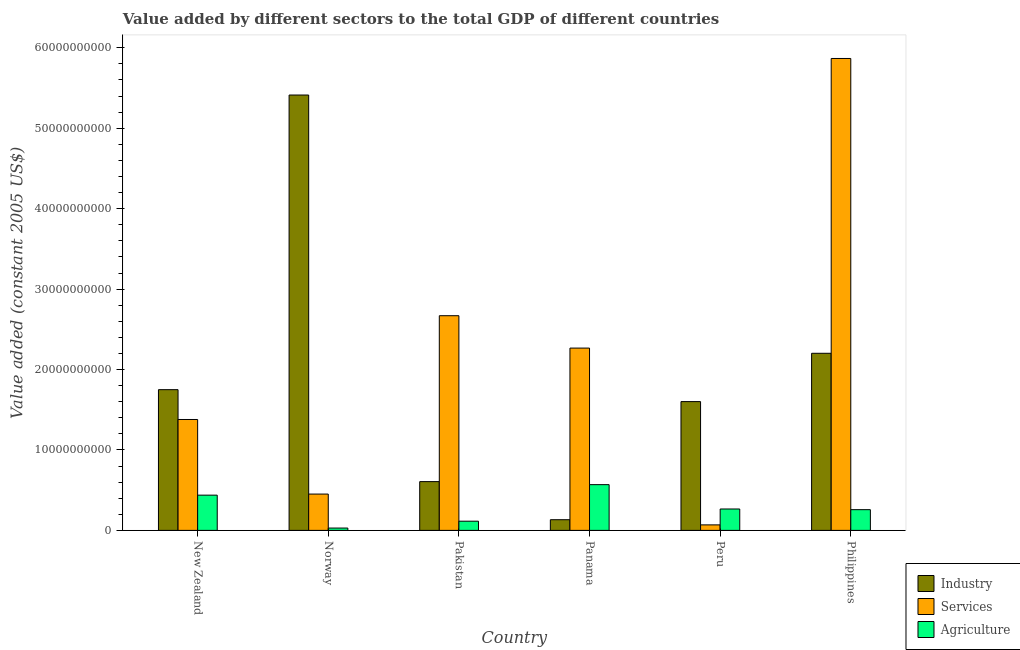How many groups of bars are there?
Offer a terse response. 6. Are the number of bars per tick equal to the number of legend labels?
Ensure brevity in your answer.  Yes. How many bars are there on the 3rd tick from the left?
Ensure brevity in your answer.  3. What is the label of the 3rd group of bars from the left?
Provide a succinct answer. Pakistan. In how many cases, is the number of bars for a given country not equal to the number of legend labels?
Offer a terse response. 0. What is the value added by services in Philippines?
Offer a terse response. 5.87e+1. Across all countries, what is the maximum value added by services?
Give a very brief answer. 5.87e+1. Across all countries, what is the minimum value added by industrial sector?
Your response must be concise. 1.33e+09. In which country was the value added by industrial sector minimum?
Ensure brevity in your answer.  Panama. What is the total value added by agricultural sector in the graph?
Ensure brevity in your answer.  1.67e+1. What is the difference between the value added by services in Norway and that in Panama?
Keep it short and to the point. -1.82e+1. What is the difference between the value added by services in Norway and the value added by agricultural sector in Pakistan?
Ensure brevity in your answer.  3.37e+09. What is the average value added by industrial sector per country?
Provide a succinct answer. 1.95e+1. What is the difference between the value added by industrial sector and value added by services in Pakistan?
Provide a succinct answer. -2.06e+1. What is the ratio of the value added by industrial sector in Panama to that in Peru?
Provide a short and direct response. 0.08. What is the difference between the highest and the second highest value added by agricultural sector?
Provide a short and direct response. 1.30e+09. What is the difference between the highest and the lowest value added by agricultural sector?
Your answer should be compact. 5.40e+09. In how many countries, is the value added by services greater than the average value added by services taken over all countries?
Your response must be concise. 3. What does the 2nd bar from the left in Philippines represents?
Your answer should be very brief. Services. What does the 3rd bar from the right in Norway represents?
Your response must be concise. Industry. Are all the bars in the graph horizontal?
Keep it short and to the point. No. Are the values on the major ticks of Y-axis written in scientific E-notation?
Offer a terse response. No. Where does the legend appear in the graph?
Provide a short and direct response. Bottom right. What is the title of the graph?
Make the answer very short. Value added by different sectors to the total GDP of different countries. What is the label or title of the Y-axis?
Give a very brief answer. Value added (constant 2005 US$). What is the Value added (constant 2005 US$) in Industry in New Zealand?
Your answer should be very brief. 1.75e+1. What is the Value added (constant 2005 US$) in Services in New Zealand?
Ensure brevity in your answer.  1.38e+1. What is the Value added (constant 2005 US$) in Agriculture in New Zealand?
Keep it short and to the point. 4.38e+09. What is the Value added (constant 2005 US$) of Industry in Norway?
Ensure brevity in your answer.  5.41e+1. What is the Value added (constant 2005 US$) of Services in Norway?
Make the answer very short. 4.51e+09. What is the Value added (constant 2005 US$) of Agriculture in Norway?
Give a very brief answer. 2.90e+08. What is the Value added (constant 2005 US$) in Industry in Pakistan?
Your response must be concise. 6.06e+09. What is the Value added (constant 2005 US$) of Services in Pakistan?
Offer a very short reply. 2.67e+1. What is the Value added (constant 2005 US$) in Agriculture in Pakistan?
Make the answer very short. 1.14e+09. What is the Value added (constant 2005 US$) of Industry in Panama?
Provide a succinct answer. 1.33e+09. What is the Value added (constant 2005 US$) of Services in Panama?
Make the answer very short. 2.27e+1. What is the Value added (constant 2005 US$) of Agriculture in Panama?
Offer a very short reply. 5.69e+09. What is the Value added (constant 2005 US$) of Industry in Peru?
Offer a very short reply. 1.60e+1. What is the Value added (constant 2005 US$) of Services in Peru?
Offer a very short reply. 6.85e+08. What is the Value added (constant 2005 US$) of Agriculture in Peru?
Make the answer very short. 2.66e+09. What is the Value added (constant 2005 US$) of Industry in Philippines?
Provide a short and direct response. 2.20e+1. What is the Value added (constant 2005 US$) of Services in Philippines?
Provide a succinct answer. 5.87e+1. What is the Value added (constant 2005 US$) of Agriculture in Philippines?
Provide a short and direct response. 2.58e+09. Across all countries, what is the maximum Value added (constant 2005 US$) of Industry?
Give a very brief answer. 5.41e+1. Across all countries, what is the maximum Value added (constant 2005 US$) in Services?
Your response must be concise. 5.87e+1. Across all countries, what is the maximum Value added (constant 2005 US$) in Agriculture?
Provide a short and direct response. 5.69e+09. Across all countries, what is the minimum Value added (constant 2005 US$) in Industry?
Provide a short and direct response. 1.33e+09. Across all countries, what is the minimum Value added (constant 2005 US$) in Services?
Offer a very short reply. 6.85e+08. Across all countries, what is the minimum Value added (constant 2005 US$) in Agriculture?
Provide a short and direct response. 2.90e+08. What is the total Value added (constant 2005 US$) in Industry in the graph?
Provide a succinct answer. 1.17e+11. What is the total Value added (constant 2005 US$) of Services in the graph?
Ensure brevity in your answer.  1.27e+11. What is the total Value added (constant 2005 US$) of Agriculture in the graph?
Give a very brief answer. 1.67e+1. What is the difference between the Value added (constant 2005 US$) of Industry in New Zealand and that in Norway?
Provide a succinct answer. -3.66e+1. What is the difference between the Value added (constant 2005 US$) of Services in New Zealand and that in Norway?
Offer a terse response. 9.27e+09. What is the difference between the Value added (constant 2005 US$) of Agriculture in New Zealand and that in Norway?
Make the answer very short. 4.09e+09. What is the difference between the Value added (constant 2005 US$) in Industry in New Zealand and that in Pakistan?
Offer a terse response. 1.14e+1. What is the difference between the Value added (constant 2005 US$) in Services in New Zealand and that in Pakistan?
Your answer should be very brief. -1.29e+1. What is the difference between the Value added (constant 2005 US$) of Agriculture in New Zealand and that in Pakistan?
Offer a very short reply. 3.24e+09. What is the difference between the Value added (constant 2005 US$) of Industry in New Zealand and that in Panama?
Make the answer very short. 1.62e+1. What is the difference between the Value added (constant 2005 US$) in Services in New Zealand and that in Panama?
Your answer should be very brief. -8.88e+09. What is the difference between the Value added (constant 2005 US$) of Agriculture in New Zealand and that in Panama?
Provide a succinct answer. -1.30e+09. What is the difference between the Value added (constant 2005 US$) in Industry in New Zealand and that in Peru?
Provide a succinct answer. 1.48e+09. What is the difference between the Value added (constant 2005 US$) in Services in New Zealand and that in Peru?
Provide a succinct answer. 1.31e+1. What is the difference between the Value added (constant 2005 US$) of Agriculture in New Zealand and that in Peru?
Give a very brief answer. 1.72e+09. What is the difference between the Value added (constant 2005 US$) of Industry in New Zealand and that in Philippines?
Your answer should be compact. -4.52e+09. What is the difference between the Value added (constant 2005 US$) of Services in New Zealand and that in Philippines?
Your response must be concise. -4.49e+1. What is the difference between the Value added (constant 2005 US$) in Agriculture in New Zealand and that in Philippines?
Offer a terse response. 1.81e+09. What is the difference between the Value added (constant 2005 US$) in Industry in Norway and that in Pakistan?
Provide a short and direct response. 4.81e+1. What is the difference between the Value added (constant 2005 US$) of Services in Norway and that in Pakistan?
Provide a succinct answer. -2.22e+1. What is the difference between the Value added (constant 2005 US$) in Agriculture in Norway and that in Pakistan?
Your answer should be very brief. -8.53e+08. What is the difference between the Value added (constant 2005 US$) of Industry in Norway and that in Panama?
Offer a very short reply. 5.28e+1. What is the difference between the Value added (constant 2005 US$) in Services in Norway and that in Panama?
Offer a terse response. -1.82e+1. What is the difference between the Value added (constant 2005 US$) in Agriculture in Norway and that in Panama?
Your answer should be very brief. -5.40e+09. What is the difference between the Value added (constant 2005 US$) of Industry in Norway and that in Peru?
Keep it short and to the point. 3.81e+1. What is the difference between the Value added (constant 2005 US$) of Services in Norway and that in Peru?
Keep it short and to the point. 3.83e+09. What is the difference between the Value added (constant 2005 US$) of Agriculture in Norway and that in Peru?
Your answer should be compact. -2.37e+09. What is the difference between the Value added (constant 2005 US$) of Industry in Norway and that in Philippines?
Give a very brief answer. 3.21e+1. What is the difference between the Value added (constant 2005 US$) in Services in Norway and that in Philippines?
Your answer should be very brief. -5.42e+1. What is the difference between the Value added (constant 2005 US$) of Agriculture in Norway and that in Philippines?
Offer a terse response. -2.29e+09. What is the difference between the Value added (constant 2005 US$) in Industry in Pakistan and that in Panama?
Your answer should be compact. 4.74e+09. What is the difference between the Value added (constant 2005 US$) in Services in Pakistan and that in Panama?
Offer a terse response. 4.03e+09. What is the difference between the Value added (constant 2005 US$) in Agriculture in Pakistan and that in Panama?
Give a very brief answer. -4.54e+09. What is the difference between the Value added (constant 2005 US$) of Industry in Pakistan and that in Peru?
Keep it short and to the point. -9.95e+09. What is the difference between the Value added (constant 2005 US$) of Services in Pakistan and that in Peru?
Make the answer very short. 2.60e+1. What is the difference between the Value added (constant 2005 US$) of Agriculture in Pakistan and that in Peru?
Your response must be concise. -1.52e+09. What is the difference between the Value added (constant 2005 US$) of Industry in Pakistan and that in Philippines?
Offer a very short reply. -1.60e+1. What is the difference between the Value added (constant 2005 US$) of Services in Pakistan and that in Philippines?
Make the answer very short. -3.20e+1. What is the difference between the Value added (constant 2005 US$) in Agriculture in Pakistan and that in Philippines?
Give a very brief answer. -1.43e+09. What is the difference between the Value added (constant 2005 US$) of Industry in Panama and that in Peru?
Provide a succinct answer. -1.47e+1. What is the difference between the Value added (constant 2005 US$) of Services in Panama and that in Peru?
Ensure brevity in your answer.  2.20e+1. What is the difference between the Value added (constant 2005 US$) in Agriculture in Panama and that in Peru?
Provide a succinct answer. 3.03e+09. What is the difference between the Value added (constant 2005 US$) of Industry in Panama and that in Philippines?
Provide a succinct answer. -2.07e+1. What is the difference between the Value added (constant 2005 US$) of Services in Panama and that in Philippines?
Give a very brief answer. -3.60e+1. What is the difference between the Value added (constant 2005 US$) of Agriculture in Panama and that in Philippines?
Provide a short and direct response. 3.11e+09. What is the difference between the Value added (constant 2005 US$) of Industry in Peru and that in Philippines?
Offer a very short reply. -6.01e+09. What is the difference between the Value added (constant 2005 US$) of Services in Peru and that in Philippines?
Ensure brevity in your answer.  -5.80e+1. What is the difference between the Value added (constant 2005 US$) of Agriculture in Peru and that in Philippines?
Your answer should be compact. 8.38e+07. What is the difference between the Value added (constant 2005 US$) of Industry in New Zealand and the Value added (constant 2005 US$) of Services in Norway?
Make the answer very short. 1.30e+1. What is the difference between the Value added (constant 2005 US$) of Industry in New Zealand and the Value added (constant 2005 US$) of Agriculture in Norway?
Provide a succinct answer. 1.72e+1. What is the difference between the Value added (constant 2005 US$) of Services in New Zealand and the Value added (constant 2005 US$) of Agriculture in Norway?
Provide a succinct answer. 1.35e+1. What is the difference between the Value added (constant 2005 US$) in Industry in New Zealand and the Value added (constant 2005 US$) in Services in Pakistan?
Ensure brevity in your answer.  -9.19e+09. What is the difference between the Value added (constant 2005 US$) of Industry in New Zealand and the Value added (constant 2005 US$) of Agriculture in Pakistan?
Offer a very short reply. 1.64e+1. What is the difference between the Value added (constant 2005 US$) in Services in New Zealand and the Value added (constant 2005 US$) in Agriculture in Pakistan?
Provide a succinct answer. 1.26e+1. What is the difference between the Value added (constant 2005 US$) in Industry in New Zealand and the Value added (constant 2005 US$) in Services in Panama?
Provide a short and direct response. -5.17e+09. What is the difference between the Value added (constant 2005 US$) in Industry in New Zealand and the Value added (constant 2005 US$) in Agriculture in Panama?
Offer a terse response. 1.18e+1. What is the difference between the Value added (constant 2005 US$) in Services in New Zealand and the Value added (constant 2005 US$) in Agriculture in Panama?
Keep it short and to the point. 8.10e+09. What is the difference between the Value added (constant 2005 US$) of Industry in New Zealand and the Value added (constant 2005 US$) of Services in Peru?
Your answer should be compact. 1.68e+1. What is the difference between the Value added (constant 2005 US$) in Industry in New Zealand and the Value added (constant 2005 US$) in Agriculture in Peru?
Give a very brief answer. 1.48e+1. What is the difference between the Value added (constant 2005 US$) in Services in New Zealand and the Value added (constant 2005 US$) in Agriculture in Peru?
Give a very brief answer. 1.11e+1. What is the difference between the Value added (constant 2005 US$) of Industry in New Zealand and the Value added (constant 2005 US$) of Services in Philippines?
Your answer should be very brief. -4.12e+1. What is the difference between the Value added (constant 2005 US$) of Industry in New Zealand and the Value added (constant 2005 US$) of Agriculture in Philippines?
Your response must be concise. 1.49e+1. What is the difference between the Value added (constant 2005 US$) in Services in New Zealand and the Value added (constant 2005 US$) in Agriculture in Philippines?
Provide a succinct answer. 1.12e+1. What is the difference between the Value added (constant 2005 US$) of Industry in Norway and the Value added (constant 2005 US$) of Services in Pakistan?
Provide a succinct answer. 2.74e+1. What is the difference between the Value added (constant 2005 US$) of Industry in Norway and the Value added (constant 2005 US$) of Agriculture in Pakistan?
Your response must be concise. 5.30e+1. What is the difference between the Value added (constant 2005 US$) of Services in Norway and the Value added (constant 2005 US$) of Agriculture in Pakistan?
Provide a short and direct response. 3.37e+09. What is the difference between the Value added (constant 2005 US$) of Industry in Norway and the Value added (constant 2005 US$) of Services in Panama?
Ensure brevity in your answer.  3.15e+1. What is the difference between the Value added (constant 2005 US$) in Industry in Norway and the Value added (constant 2005 US$) in Agriculture in Panama?
Offer a terse response. 4.84e+1. What is the difference between the Value added (constant 2005 US$) in Services in Norway and the Value added (constant 2005 US$) in Agriculture in Panama?
Give a very brief answer. -1.17e+09. What is the difference between the Value added (constant 2005 US$) of Industry in Norway and the Value added (constant 2005 US$) of Services in Peru?
Give a very brief answer. 5.34e+1. What is the difference between the Value added (constant 2005 US$) in Industry in Norway and the Value added (constant 2005 US$) in Agriculture in Peru?
Your response must be concise. 5.15e+1. What is the difference between the Value added (constant 2005 US$) in Services in Norway and the Value added (constant 2005 US$) in Agriculture in Peru?
Make the answer very short. 1.85e+09. What is the difference between the Value added (constant 2005 US$) of Industry in Norway and the Value added (constant 2005 US$) of Services in Philippines?
Offer a terse response. -4.54e+09. What is the difference between the Value added (constant 2005 US$) of Industry in Norway and the Value added (constant 2005 US$) of Agriculture in Philippines?
Your answer should be compact. 5.16e+1. What is the difference between the Value added (constant 2005 US$) in Services in Norway and the Value added (constant 2005 US$) in Agriculture in Philippines?
Keep it short and to the point. 1.94e+09. What is the difference between the Value added (constant 2005 US$) in Industry in Pakistan and the Value added (constant 2005 US$) in Services in Panama?
Make the answer very short. -1.66e+1. What is the difference between the Value added (constant 2005 US$) in Industry in Pakistan and the Value added (constant 2005 US$) in Agriculture in Panama?
Make the answer very short. 3.77e+08. What is the difference between the Value added (constant 2005 US$) of Services in Pakistan and the Value added (constant 2005 US$) of Agriculture in Panama?
Keep it short and to the point. 2.10e+1. What is the difference between the Value added (constant 2005 US$) of Industry in Pakistan and the Value added (constant 2005 US$) of Services in Peru?
Your answer should be compact. 5.38e+09. What is the difference between the Value added (constant 2005 US$) of Industry in Pakistan and the Value added (constant 2005 US$) of Agriculture in Peru?
Give a very brief answer. 3.40e+09. What is the difference between the Value added (constant 2005 US$) of Services in Pakistan and the Value added (constant 2005 US$) of Agriculture in Peru?
Your answer should be compact. 2.40e+1. What is the difference between the Value added (constant 2005 US$) of Industry in Pakistan and the Value added (constant 2005 US$) of Services in Philippines?
Provide a succinct answer. -5.26e+1. What is the difference between the Value added (constant 2005 US$) in Industry in Pakistan and the Value added (constant 2005 US$) in Agriculture in Philippines?
Your answer should be compact. 3.49e+09. What is the difference between the Value added (constant 2005 US$) in Services in Pakistan and the Value added (constant 2005 US$) in Agriculture in Philippines?
Your response must be concise. 2.41e+1. What is the difference between the Value added (constant 2005 US$) of Industry in Panama and the Value added (constant 2005 US$) of Services in Peru?
Provide a short and direct response. 6.44e+08. What is the difference between the Value added (constant 2005 US$) in Industry in Panama and the Value added (constant 2005 US$) in Agriculture in Peru?
Your answer should be very brief. -1.33e+09. What is the difference between the Value added (constant 2005 US$) of Services in Panama and the Value added (constant 2005 US$) of Agriculture in Peru?
Your response must be concise. 2.00e+1. What is the difference between the Value added (constant 2005 US$) in Industry in Panama and the Value added (constant 2005 US$) in Services in Philippines?
Keep it short and to the point. -5.73e+1. What is the difference between the Value added (constant 2005 US$) of Industry in Panama and the Value added (constant 2005 US$) of Agriculture in Philippines?
Offer a very short reply. -1.25e+09. What is the difference between the Value added (constant 2005 US$) of Services in Panama and the Value added (constant 2005 US$) of Agriculture in Philippines?
Provide a short and direct response. 2.01e+1. What is the difference between the Value added (constant 2005 US$) in Industry in Peru and the Value added (constant 2005 US$) in Services in Philippines?
Your answer should be compact. -4.27e+1. What is the difference between the Value added (constant 2005 US$) of Industry in Peru and the Value added (constant 2005 US$) of Agriculture in Philippines?
Give a very brief answer. 1.34e+1. What is the difference between the Value added (constant 2005 US$) of Services in Peru and the Value added (constant 2005 US$) of Agriculture in Philippines?
Your response must be concise. -1.89e+09. What is the average Value added (constant 2005 US$) of Industry per country?
Provide a succinct answer. 1.95e+1. What is the average Value added (constant 2005 US$) in Services per country?
Your answer should be compact. 2.12e+1. What is the average Value added (constant 2005 US$) in Agriculture per country?
Your answer should be very brief. 2.79e+09. What is the difference between the Value added (constant 2005 US$) of Industry and Value added (constant 2005 US$) of Services in New Zealand?
Your answer should be very brief. 3.71e+09. What is the difference between the Value added (constant 2005 US$) of Industry and Value added (constant 2005 US$) of Agriculture in New Zealand?
Your response must be concise. 1.31e+1. What is the difference between the Value added (constant 2005 US$) of Services and Value added (constant 2005 US$) of Agriculture in New Zealand?
Offer a terse response. 9.40e+09. What is the difference between the Value added (constant 2005 US$) of Industry and Value added (constant 2005 US$) of Services in Norway?
Make the answer very short. 4.96e+1. What is the difference between the Value added (constant 2005 US$) of Industry and Value added (constant 2005 US$) of Agriculture in Norway?
Ensure brevity in your answer.  5.38e+1. What is the difference between the Value added (constant 2005 US$) of Services and Value added (constant 2005 US$) of Agriculture in Norway?
Your response must be concise. 4.22e+09. What is the difference between the Value added (constant 2005 US$) of Industry and Value added (constant 2005 US$) of Services in Pakistan?
Your answer should be compact. -2.06e+1. What is the difference between the Value added (constant 2005 US$) in Industry and Value added (constant 2005 US$) in Agriculture in Pakistan?
Keep it short and to the point. 4.92e+09. What is the difference between the Value added (constant 2005 US$) in Services and Value added (constant 2005 US$) in Agriculture in Pakistan?
Make the answer very short. 2.55e+1. What is the difference between the Value added (constant 2005 US$) of Industry and Value added (constant 2005 US$) of Services in Panama?
Offer a very short reply. -2.13e+1. What is the difference between the Value added (constant 2005 US$) of Industry and Value added (constant 2005 US$) of Agriculture in Panama?
Offer a terse response. -4.36e+09. What is the difference between the Value added (constant 2005 US$) in Services and Value added (constant 2005 US$) in Agriculture in Panama?
Make the answer very short. 1.70e+1. What is the difference between the Value added (constant 2005 US$) in Industry and Value added (constant 2005 US$) in Services in Peru?
Keep it short and to the point. 1.53e+1. What is the difference between the Value added (constant 2005 US$) of Industry and Value added (constant 2005 US$) of Agriculture in Peru?
Provide a short and direct response. 1.34e+1. What is the difference between the Value added (constant 2005 US$) in Services and Value added (constant 2005 US$) in Agriculture in Peru?
Offer a very short reply. -1.98e+09. What is the difference between the Value added (constant 2005 US$) in Industry and Value added (constant 2005 US$) in Services in Philippines?
Keep it short and to the point. -3.67e+1. What is the difference between the Value added (constant 2005 US$) in Industry and Value added (constant 2005 US$) in Agriculture in Philippines?
Offer a very short reply. 1.94e+1. What is the difference between the Value added (constant 2005 US$) in Services and Value added (constant 2005 US$) in Agriculture in Philippines?
Keep it short and to the point. 5.61e+1. What is the ratio of the Value added (constant 2005 US$) in Industry in New Zealand to that in Norway?
Your answer should be compact. 0.32. What is the ratio of the Value added (constant 2005 US$) of Services in New Zealand to that in Norway?
Keep it short and to the point. 3.05. What is the ratio of the Value added (constant 2005 US$) in Agriculture in New Zealand to that in Norway?
Provide a succinct answer. 15.1. What is the ratio of the Value added (constant 2005 US$) in Industry in New Zealand to that in Pakistan?
Your response must be concise. 2.89. What is the ratio of the Value added (constant 2005 US$) in Services in New Zealand to that in Pakistan?
Offer a terse response. 0.52. What is the ratio of the Value added (constant 2005 US$) of Agriculture in New Zealand to that in Pakistan?
Make the answer very short. 3.83. What is the ratio of the Value added (constant 2005 US$) in Industry in New Zealand to that in Panama?
Provide a short and direct response. 13.17. What is the ratio of the Value added (constant 2005 US$) of Services in New Zealand to that in Panama?
Ensure brevity in your answer.  0.61. What is the ratio of the Value added (constant 2005 US$) of Agriculture in New Zealand to that in Panama?
Ensure brevity in your answer.  0.77. What is the ratio of the Value added (constant 2005 US$) in Industry in New Zealand to that in Peru?
Ensure brevity in your answer.  1.09. What is the ratio of the Value added (constant 2005 US$) in Services in New Zealand to that in Peru?
Provide a succinct answer. 20.13. What is the ratio of the Value added (constant 2005 US$) in Agriculture in New Zealand to that in Peru?
Ensure brevity in your answer.  1.65. What is the ratio of the Value added (constant 2005 US$) in Industry in New Zealand to that in Philippines?
Offer a very short reply. 0.79. What is the ratio of the Value added (constant 2005 US$) in Services in New Zealand to that in Philippines?
Provide a short and direct response. 0.23. What is the ratio of the Value added (constant 2005 US$) in Agriculture in New Zealand to that in Philippines?
Keep it short and to the point. 1.7. What is the ratio of the Value added (constant 2005 US$) in Industry in Norway to that in Pakistan?
Make the answer very short. 8.93. What is the ratio of the Value added (constant 2005 US$) of Services in Norway to that in Pakistan?
Your response must be concise. 0.17. What is the ratio of the Value added (constant 2005 US$) of Agriculture in Norway to that in Pakistan?
Offer a terse response. 0.25. What is the ratio of the Value added (constant 2005 US$) of Industry in Norway to that in Panama?
Your response must be concise. 40.74. What is the ratio of the Value added (constant 2005 US$) in Services in Norway to that in Panama?
Keep it short and to the point. 0.2. What is the ratio of the Value added (constant 2005 US$) in Agriculture in Norway to that in Panama?
Provide a succinct answer. 0.05. What is the ratio of the Value added (constant 2005 US$) in Industry in Norway to that in Peru?
Your response must be concise. 3.38. What is the ratio of the Value added (constant 2005 US$) of Services in Norway to that in Peru?
Your response must be concise. 6.59. What is the ratio of the Value added (constant 2005 US$) in Agriculture in Norway to that in Peru?
Provide a succinct answer. 0.11. What is the ratio of the Value added (constant 2005 US$) of Industry in Norway to that in Philippines?
Make the answer very short. 2.46. What is the ratio of the Value added (constant 2005 US$) in Services in Norway to that in Philippines?
Your answer should be compact. 0.08. What is the ratio of the Value added (constant 2005 US$) in Agriculture in Norway to that in Philippines?
Provide a succinct answer. 0.11. What is the ratio of the Value added (constant 2005 US$) of Industry in Pakistan to that in Panama?
Your answer should be very brief. 4.56. What is the ratio of the Value added (constant 2005 US$) in Services in Pakistan to that in Panama?
Offer a very short reply. 1.18. What is the ratio of the Value added (constant 2005 US$) of Agriculture in Pakistan to that in Panama?
Provide a succinct answer. 0.2. What is the ratio of the Value added (constant 2005 US$) of Industry in Pakistan to that in Peru?
Make the answer very short. 0.38. What is the ratio of the Value added (constant 2005 US$) in Services in Pakistan to that in Peru?
Provide a short and direct response. 38.97. What is the ratio of the Value added (constant 2005 US$) in Agriculture in Pakistan to that in Peru?
Offer a very short reply. 0.43. What is the ratio of the Value added (constant 2005 US$) of Industry in Pakistan to that in Philippines?
Your answer should be compact. 0.28. What is the ratio of the Value added (constant 2005 US$) of Services in Pakistan to that in Philippines?
Provide a succinct answer. 0.45. What is the ratio of the Value added (constant 2005 US$) in Agriculture in Pakistan to that in Philippines?
Your response must be concise. 0.44. What is the ratio of the Value added (constant 2005 US$) in Industry in Panama to that in Peru?
Your answer should be compact. 0.08. What is the ratio of the Value added (constant 2005 US$) of Services in Panama to that in Peru?
Provide a short and direct response. 33.1. What is the ratio of the Value added (constant 2005 US$) in Agriculture in Panama to that in Peru?
Provide a succinct answer. 2.14. What is the ratio of the Value added (constant 2005 US$) of Industry in Panama to that in Philippines?
Offer a very short reply. 0.06. What is the ratio of the Value added (constant 2005 US$) in Services in Panama to that in Philippines?
Your response must be concise. 0.39. What is the ratio of the Value added (constant 2005 US$) of Agriculture in Panama to that in Philippines?
Your answer should be very brief. 2.21. What is the ratio of the Value added (constant 2005 US$) in Industry in Peru to that in Philippines?
Make the answer very short. 0.73. What is the ratio of the Value added (constant 2005 US$) of Services in Peru to that in Philippines?
Offer a very short reply. 0.01. What is the ratio of the Value added (constant 2005 US$) of Agriculture in Peru to that in Philippines?
Provide a short and direct response. 1.03. What is the difference between the highest and the second highest Value added (constant 2005 US$) of Industry?
Keep it short and to the point. 3.21e+1. What is the difference between the highest and the second highest Value added (constant 2005 US$) of Services?
Offer a very short reply. 3.20e+1. What is the difference between the highest and the second highest Value added (constant 2005 US$) of Agriculture?
Make the answer very short. 1.30e+09. What is the difference between the highest and the lowest Value added (constant 2005 US$) in Industry?
Ensure brevity in your answer.  5.28e+1. What is the difference between the highest and the lowest Value added (constant 2005 US$) in Services?
Offer a very short reply. 5.80e+1. What is the difference between the highest and the lowest Value added (constant 2005 US$) in Agriculture?
Ensure brevity in your answer.  5.40e+09. 